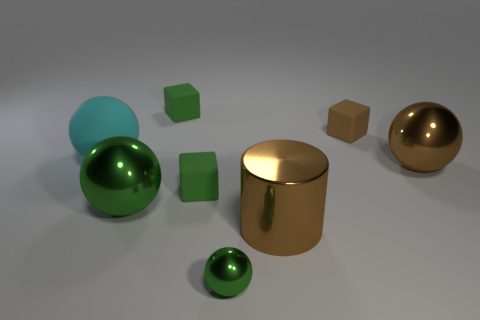What number of green spheres are made of the same material as the cylinder?
Keep it short and to the point. 2. The shiny object that is to the left of the small green metal sphere on the left side of the matte cube to the right of the large brown cylinder is what color?
Offer a very short reply. Green. Is the size of the cyan object the same as the brown cylinder?
Give a very brief answer. Yes. Are there any other things that are the same shape as the large green thing?
Offer a very short reply. Yes. How many objects are tiny green objects behind the tiny brown matte cube or big cyan metallic spheres?
Your answer should be very brief. 1. Is the tiny brown object the same shape as the large green metallic thing?
Keep it short and to the point. No. What number of other objects are there of the same size as the cyan matte ball?
Provide a succinct answer. 3. The tiny metal sphere is what color?
Provide a short and direct response. Green. How many big things are either brown shiny things or shiny objects?
Give a very brief answer. 3. There is a metallic thing in front of the shiny cylinder; is its size the same as the metallic sphere that is right of the cylinder?
Offer a terse response. No. 